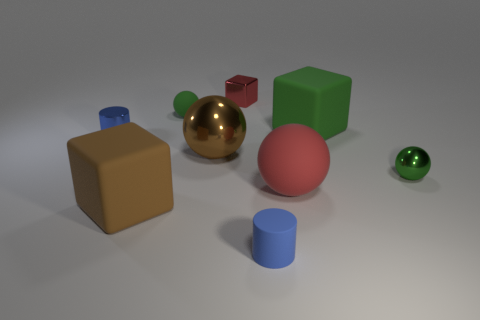Subtract all gray balls. Subtract all purple blocks. How many balls are left? 4 Add 1 green metal objects. How many objects exist? 10 Subtract all balls. How many objects are left? 5 Add 1 small blue cylinders. How many small blue cylinders exist? 3 Subtract 0 cyan cubes. How many objects are left? 9 Subtract all blue things. Subtract all big red matte things. How many objects are left? 6 Add 9 brown rubber objects. How many brown rubber objects are left? 10 